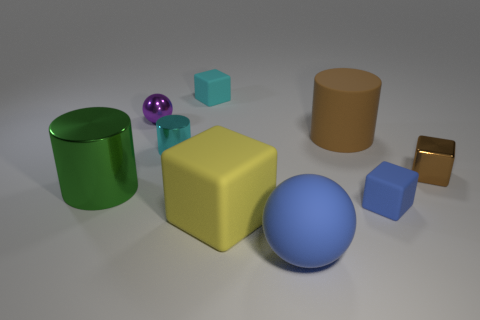Subtract all cyan cubes. How many cubes are left? 3 Subtract all yellow cubes. How many cubes are left? 3 Add 1 big gray rubber cylinders. How many objects exist? 10 Subtract all gray cubes. Subtract all purple balls. How many cubes are left? 4 Subtract 1 green cylinders. How many objects are left? 8 Subtract all spheres. How many objects are left? 7 Subtract all shiny objects. Subtract all tiny blue rubber objects. How many objects are left? 4 Add 1 big brown objects. How many big brown objects are left? 2 Add 7 small cyan rubber balls. How many small cyan rubber balls exist? 7 